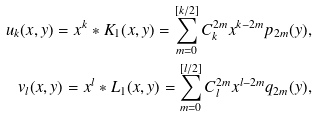<formula> <loc_0><loc_0><loc_500><loc_500>u _ { k } ( x , y ) = x ^ { k } * K _ { 1 } ( x , y ) = \sum _ { m = 0 } ^ { [ k / 2 ] } C _ { k } ^ { 2 m } x ^ { k - 2 m } p _ { 2 m } ( y ) , \\ v _ { l } ( x , y ) = x ^ { l } * L _ { 1 } ( x , y ) = \sum _ { m = 0 } ^ { [ l / 2 ] } C _ { l } ^ { 2 m } x ^ { l - 2 m } q _ { 2 m } ( y ) ,</formula> 